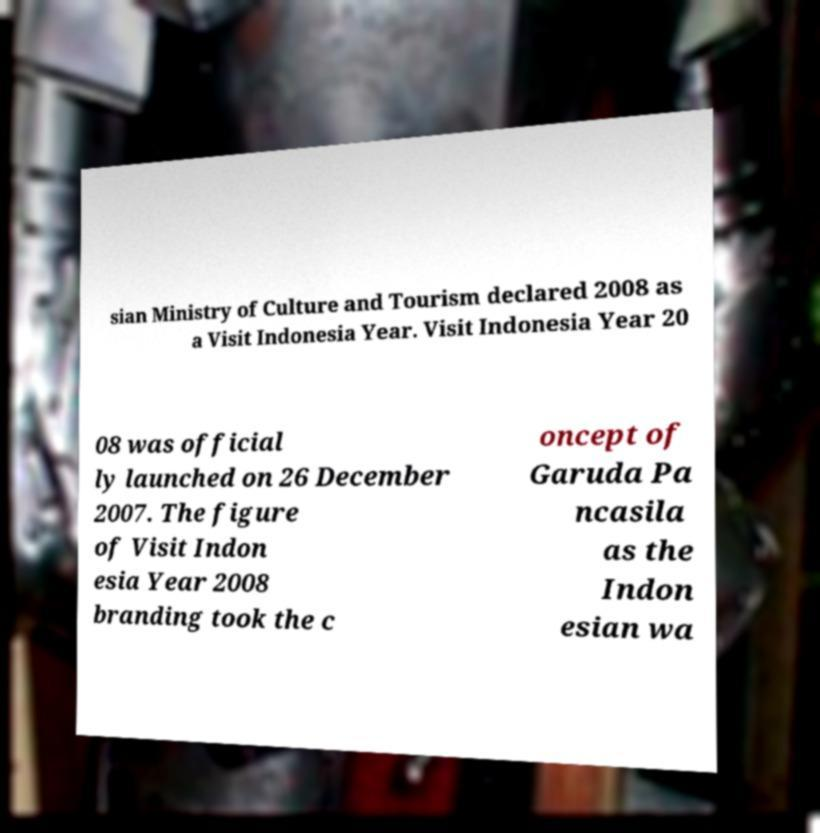I need the written content from this picture converted into text. Can you do that? sian Ministry of Culture and Tourism declared 2008 as a Visit Indonesia Year. Visit Indonesia Year 20 08 was official ly launched on 26 December 2007. The figure of Visit Indon esia Year 2008 branding took the c oncept of Garuda Pa ncasila as the Indon esian wa 